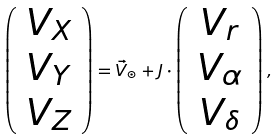Convert formula to latex. <formula><loc_0><loc_0><loc_500><loc_500>\left ( \begin{array} { c } V _ { X } \\ V _ { Y } \\ V _ { Z } \end{array} \right ) = \vec { V } _ { \odot } + J \cdot \left ( \begin{array} { c } V _ { r } \\ V _ { \alpha } \\ V _ { \delta } \end{array} \right ) ,</formula> 